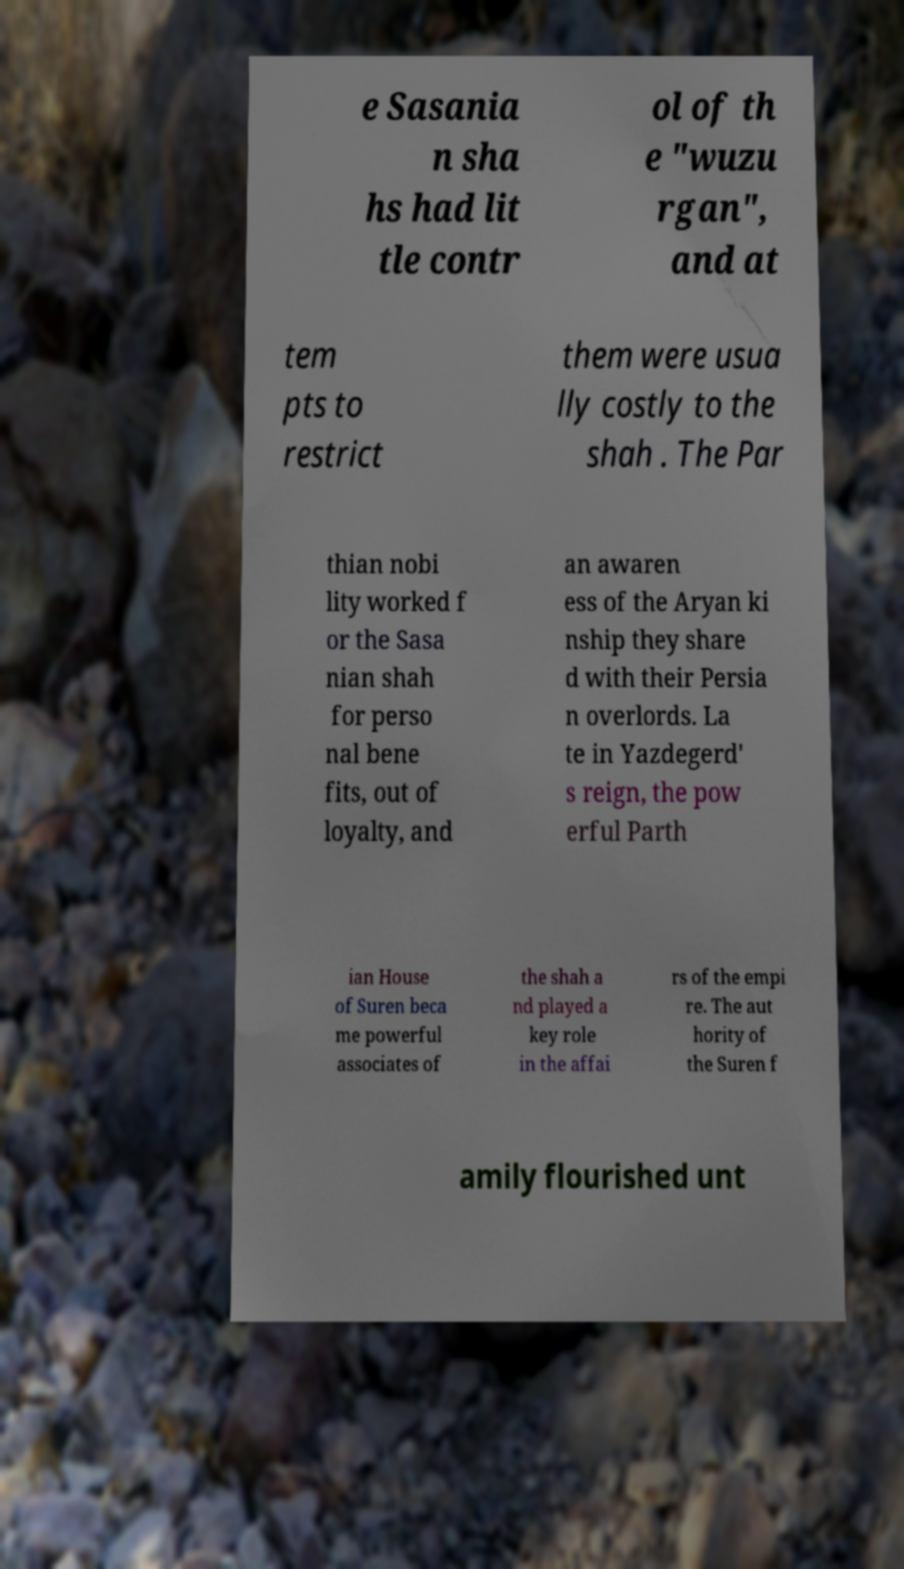Can you accurately transcribe the text from the provided image for me? e Sasania n sha hs had lit tle contr ol of th e "wuzu rgan", and at tem pts to restrict them were usua lly costly to the shah . The Par thian nobi lity worked f or the Sasa nian shah for perso nal bene fits, out of loyalty, and an awaren ess of the Aryan ki nship they share d with their Persia n overlords. La te in Yazdegerd' s reign, the pow erful Parth ian House of Suren beca me powerful associates of the shah a nd played a key role in the affai rs of the empi re. The aut hority of the Suren f amily flourished unt 